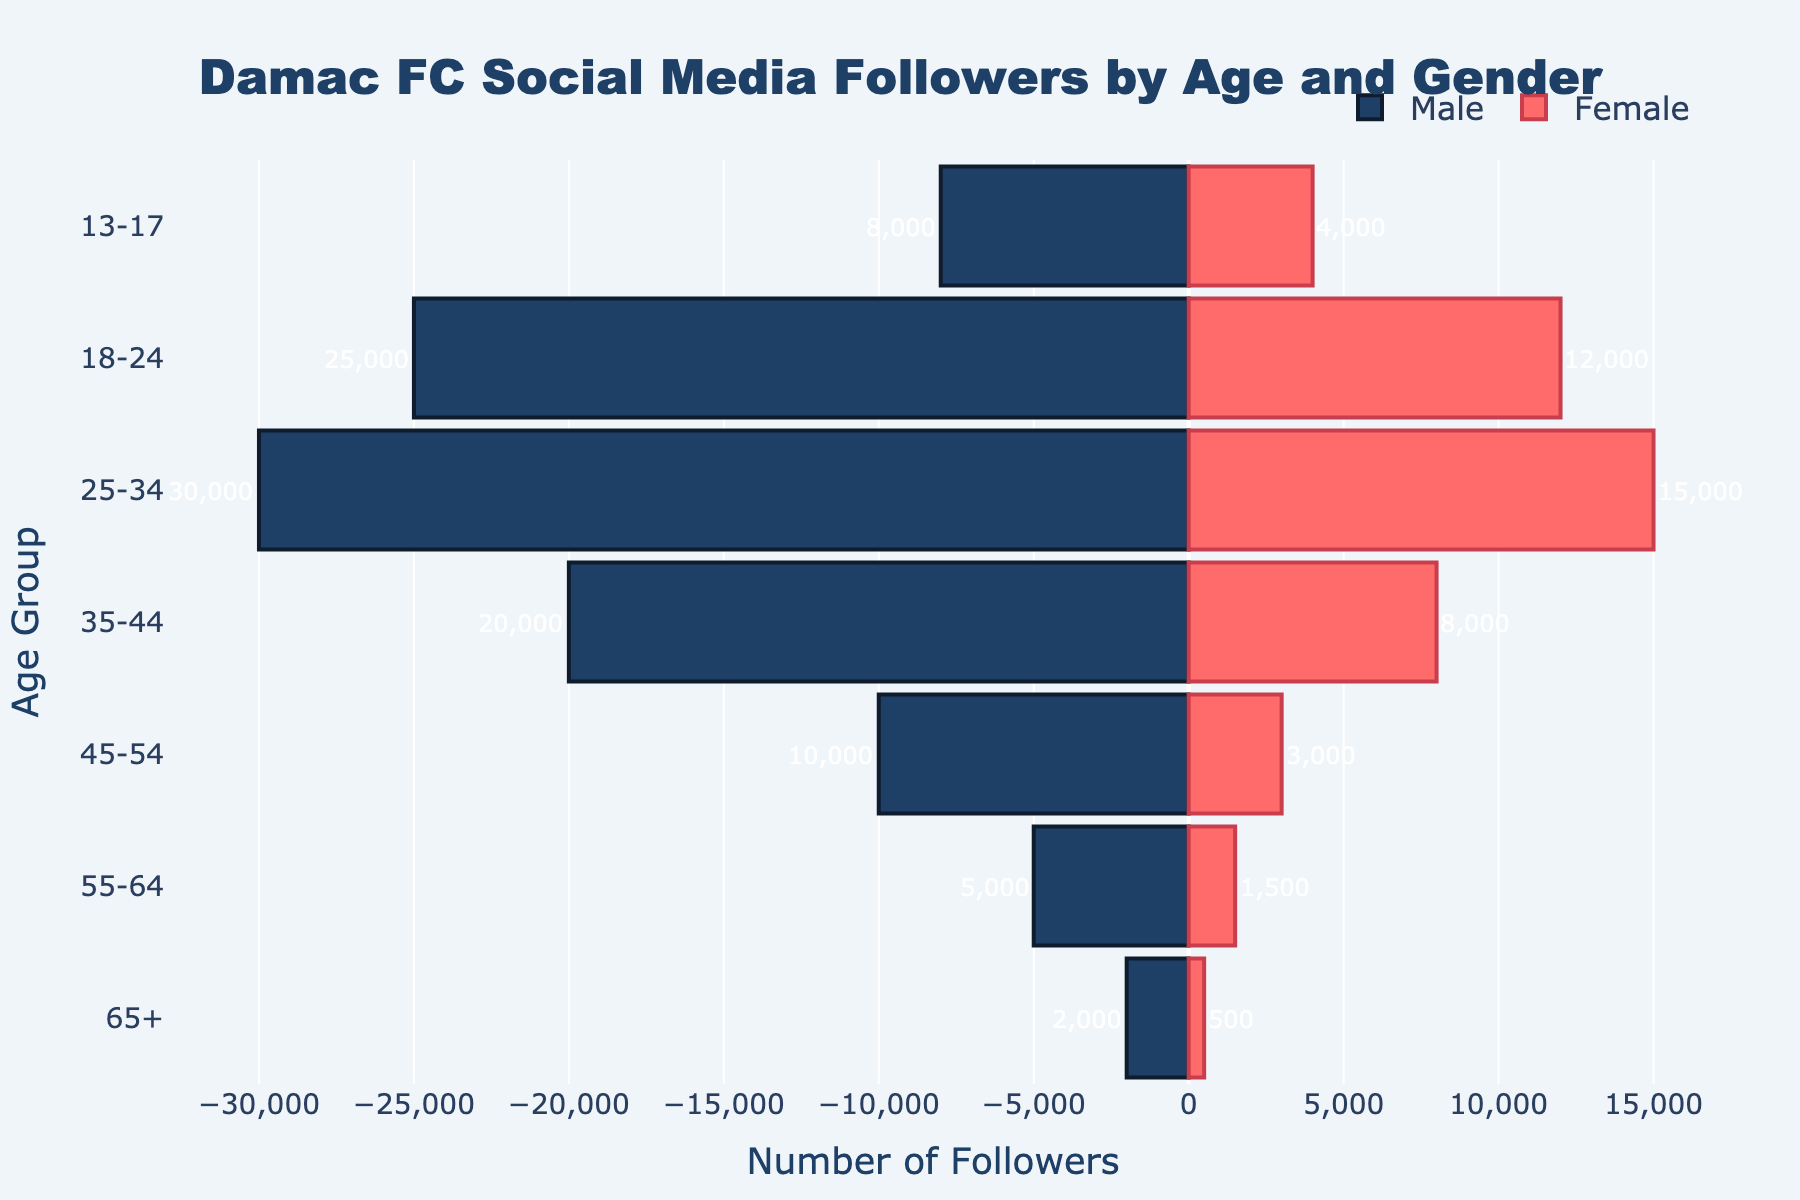What is the title of the figure? The title is located at the top of the figure and it summarizes the main subject of the data presented. The text is bold and clearly visible.
Answer: Damac FC Social Media Followers by Age and Gender How many age groups are displayed in the figure? Count the number of distinct labels on the y-axis which represent different age groups.
Answer: 7 What is the highest number of male followers in any age group for Damac FC? Look for the bar representing the highest male follower count among all age groups (the longest bar on the left side).
Answer: 30,000 Which age group has the smallest number of female followers for Damac FC? Identify the shortest bar on the right side of the figure that indicates female followers, and refer to its corresponding age group on the y-axis.
Answer: 65+ How many more male followers are there in the 25-34 age group compared to female followers in the same age group for Damac FC? Subtract the number of female followers from the number of male followers in the 25-34 age group.
Answer: 15,000 Which gender has more followers in the 35-44 age group for Damac FC and by how much? Compare the lengths of the bars for male and female in the 35-44 age group and find the difference between them.
Answer: Male, 12,000 In which age group is the difference between male and female followers the smallest for Damac FC? Calculate the difference between male and female followers for each age group and identify the one with the smallest difference.
Answer: 13-17 What is the total number of Damac FC followers in the 18-24 age group? Add the number of male and female followers in the 18-24 age group.
Answer: 37,000 Compare the total followers of Damac FC and Al-Hilal in the 45-54 age group. Which club has more followers and by how much? Sum the male and female followers for both Damac FC and Al-Hilal in the 45-54 age group and compare the totals to find the difference.
Answer: Al-Hilal, 12,000 What trend can you observe about the number of followers as age increases for Damac FC? Examine the lengths of the bars from the youngest to the oldest age groups for both genders and describe the observed pattern.
Answer: The number of followers generally decreases as age increases 